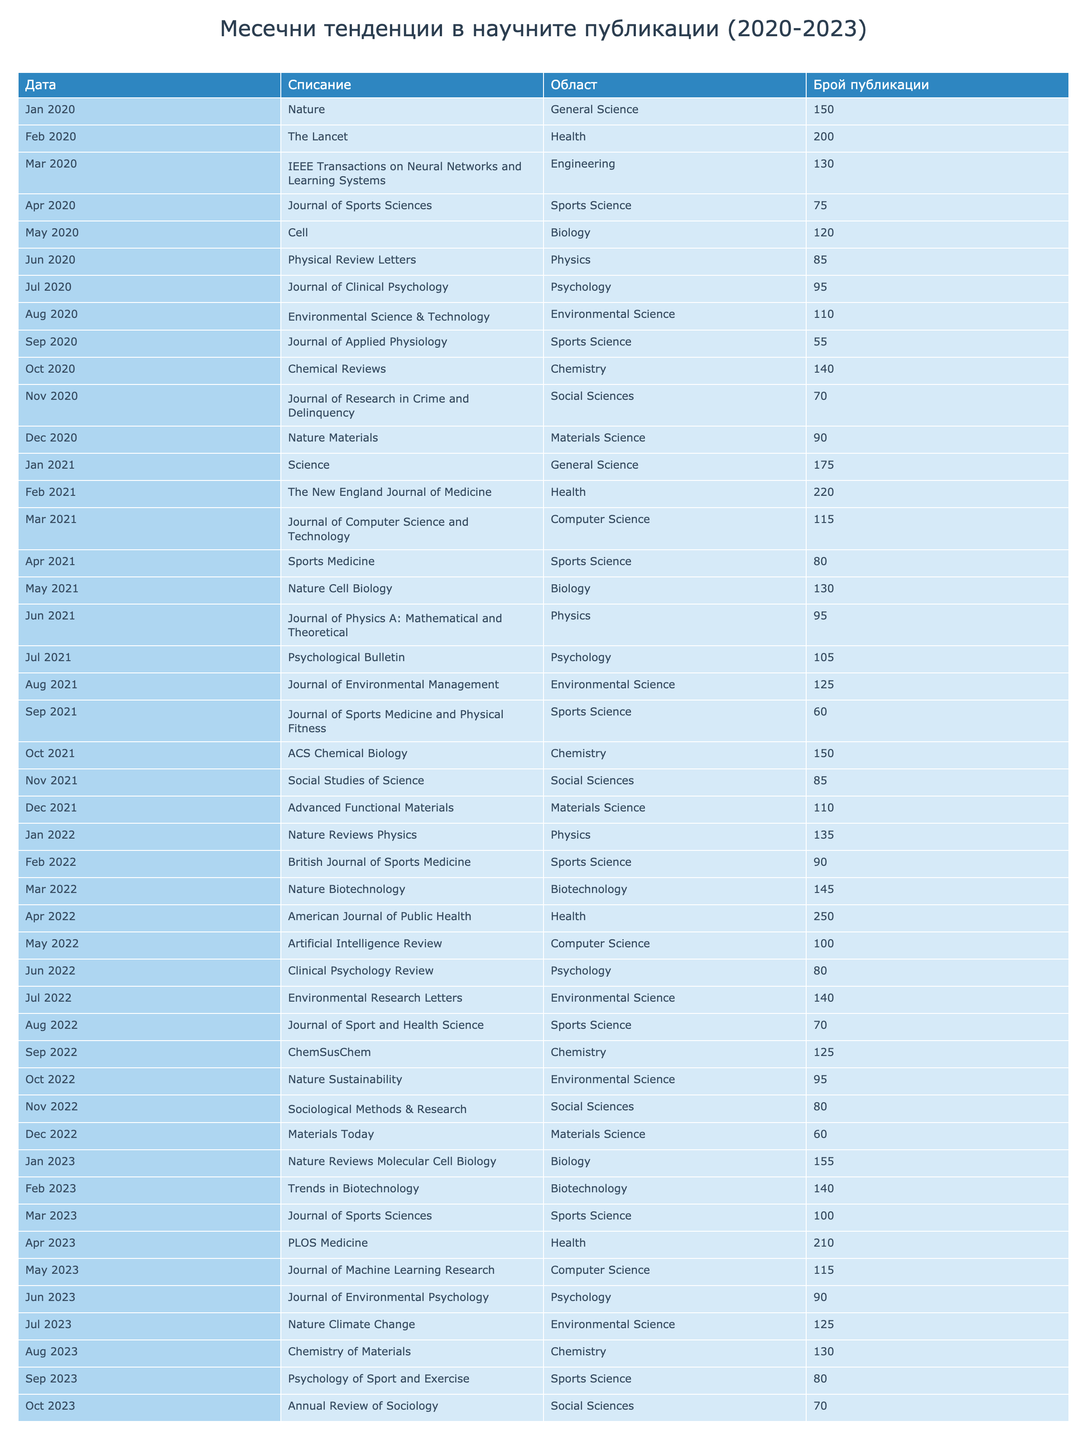What is the total number of publications in April 2022? To find the total number of publications in April 2022, I search for the specific row in the table for April 2022, where the journal listed is "American Journal of Public Health" and the publications count is 250. Thus, the total for that month is 250.
Answer: 250 Which journal had the highest number of publications in March 2021? By examining the entries for March 2021, I identify the journal "Journal of Computer Science and Technology" with 115 publications. However, I need to see if there are other journals in that month like "Journal of Sports Medicine and Physical Fitness" which has 60, so the highest remains 115 from the former journal.
Answer: 115 What is the average number of publications for Sports Science journals across all years? To find the average number of publications for Sports Science journals, I first gather all publication counts for those journals which are 75, 55, 80, 60, 90, 70, 100, and 80. Adding these together gives 75 + 55 + 80 + 60 + 90 + 70 + 100 + 80 = 610. Then, I count the total entries which is 8. Finally, the average is 610 divided by 8, which equals 76.25.
Answer: 76.25 Did the publication count for Nature increase from 2020 to 2023? I look at the entries for "Nature" in the years 2020 and 2023. In 2020, it had 150 publications, and in 2023, "Nature Reviews Molecular Cell Biology" is listed with 155. Although the publication is not the same title, it indicates growth in the overall productivity. So, the conclusion is yes, there is an increase in the broader Nature-related publications.
Answer: Yes Which month in 2022 had the highest number of publications and what was the count? I review all months in 2022, noting the publication counts which are: January 135, February 90, March 145, April 250, May 100, June 80, July 140, August 70, September 125, October 95, November 80, December 60. The month with the highest count is April with 250 publications.
Answer: April, 250 